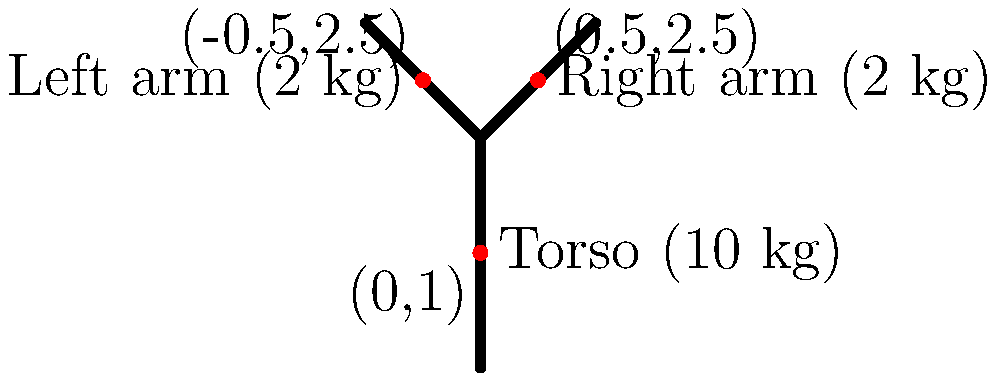A simplified human body model consists of three segments: a torso (10 kg) and two arms (2 kg each). The center of mass for each segment is located at the following coordinates: torso (0,1), right arm (0.5,2.5), and left arm (-0.5,2.5). Calculate the x-coordinate of the center of mass for the entire body model. To calculate the x-coordinate of the center of mass for the entire body model, we'll use the formula:

$$ x_{CM} = \frac{\sum_{i=1}^n m_i x_i}{\sum_{i=1}^n m_i} $$

Where:
$x_{CM}$ is the x-coordinate of the center of mass
$m_i$ is the mass of each segment
$x_i$ is the x-coordinate of each segment's center of mass

Step 1: Identify the masses and x-coordinates for each segment:
- Torso: $m_1 = 10$ kg, $x_1 = 0$
- Right arm: $m_2 = 2$ kg, $x_2 = 0.5$
- Left arm: $m_3 = 2$ kg, $x_3 = -0.5$

Step 2: Calculate the total mass:
$$ \sum_{i=1}^n m_i = 10 + 2 + 2 = 14 \text{ kg} $$

Step 3: Calculate the sum of mass-weighted x-coordinates:
$$ \sum_{i=1}^n m_i x_i = (10 \times 0) + (2 \times 0.5) + (2 \times -0.5) = 0 $$

Step 4: Apply the formula:
$$ x_{CM} = \frac{\sum_{i=1}^n m_i x_i}{\sum_{i=1}^n m_i} = \frac{0}{14} = 0 $$

Therefore, the x-coordinate of the center of mass for the entire body model is 0.
Answer: 0 